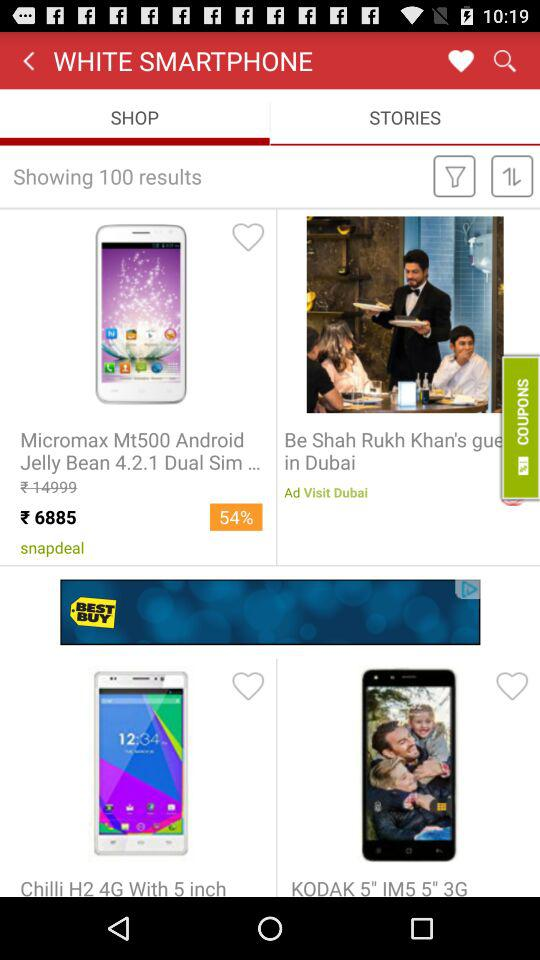What option has been chosen? The option chosen is "SHOP". 